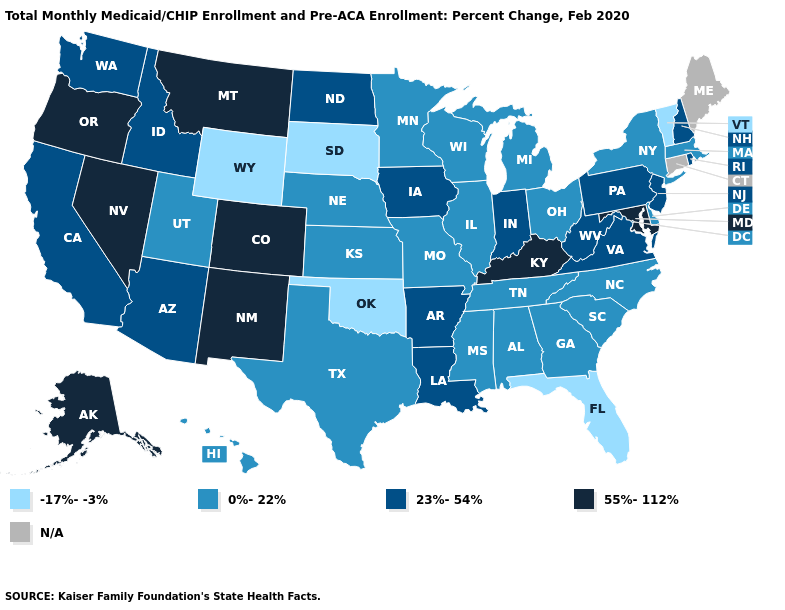Which states have the highest value in the USA?
Write a very short answer. Alaska, Colorado, Kentucky, Maryland, Montana, Nevada, New Mexico, Oregon. How many symbols are there in the legend?
Write a very short answer. 5. What is the value of Delaware?
Be succinct. 0%-22%. Among the states that border Pennsylvania , does Delaware have the highest value?
Keep it brief. No. What is the value of Alabama?
Answer briefly. 0%-22%. Does Florida have the lowest value in the USA?
Concise answer only. Yes. What is the lowest value in the USA?
Short answer required. -17%--3%. What is the lowest value in states that border Florida?
Keep it brief. 0%-22%. Name the states that have a value in the range 23%-54%?
Quick response, please. Arizona, Arkansas, California, Idaho, Indiana, Iowa, Louisiana, New Hampshire, New Jersey, North Dakota, Pennsylvania, Rhode Island, Virginia, Washington, West Virginia. What is the value of Arkansas?
Write a very short answer. 23%-54%. Which states have the lowest value in the MidWest?
Keep it brief. South Dakota. What is the highest value in the West ?
Concise answer only. 55%-112%. What is the lowest value in the USA?
Keep it brief. -17%--3%. Among the states that border Alabama , which have the highest value?
Answer briefly. Georgia, Mississippi, Tennessee. What is the value of Hawaii?
Concise answer only. 0%-22%. 